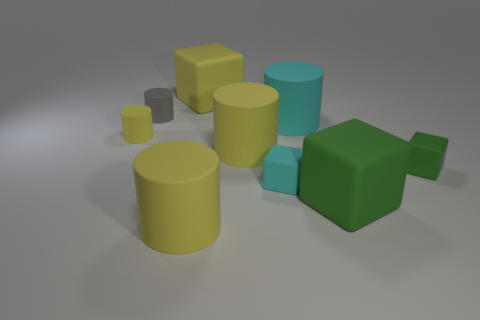How many small things are either purple rubber balls or matte blocks?
Provide a short and direct response. 2. There is a large green thing; how many small objects are right of it?
Give a very brief answer. 1. There is a green thing that is the same size as the cyan matte cube; what is its shape?
Offer a terse response. Cube. What number of cyan things are either large matte cylinders or tiny blocks?
Give a very brief answer. 2. What number of other gray matte cylinders are the same size as the gray cylinder?
Make the answer very short. 0. How many objects are green matte cylinders or large yellow rubber objects that are in front of the tiny green cube?
Keep it short and to the point. 1. There is a yellow matte object that is behind the gray matte thing; is it the same size as the yellow thing that is left of the small gray object?
Make the answer very short. No. What number of tiny cyan things have the same shape as the small green rubber thing?
Your response must be concise. 1. What is the shape of the gray object that is the same material as the large green block?
Offer a very short reply. Cylinder. Is the size of the gray cylinder the same as the cyan rubber object that is in front of the small green matte cube?
Make the answer very short. Yes. 